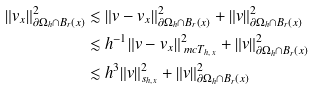Convert formula to latex. <formula><loc_0><loc_0><loc_500><loc_500>\| v _ { x } \| ^ { 2 } _ { \partial \Omega _ { h } \cap B _ { r } ( x ) } & \lesssim \| v - v _ { x } \| ^ { 2 } _ { \partial \Omega _ { h } \cap B _ { r } ( x ) } + \| v \| ^ { 2 } _ { \partial \Omega _ { h } \cap B _ { r } ( x ) } \\ & \lesssim h ^ { - 1 } \| v - v _ { x } \| ^ { 2 } _ { \ m c T _ { h , x } } + \| v \| ^ { 2 } _ { \partial \Omega _ { h } \cap B _ { r } ( x ) } \\ & \lesssim h ^ { 3 } \| v \| ^ { 2 } _ { s _ { h , x } } + \| v \| ^ { 2 } _ { \partial \Omega _ { h } \cap B _ { r } ( x ) }</formula> 